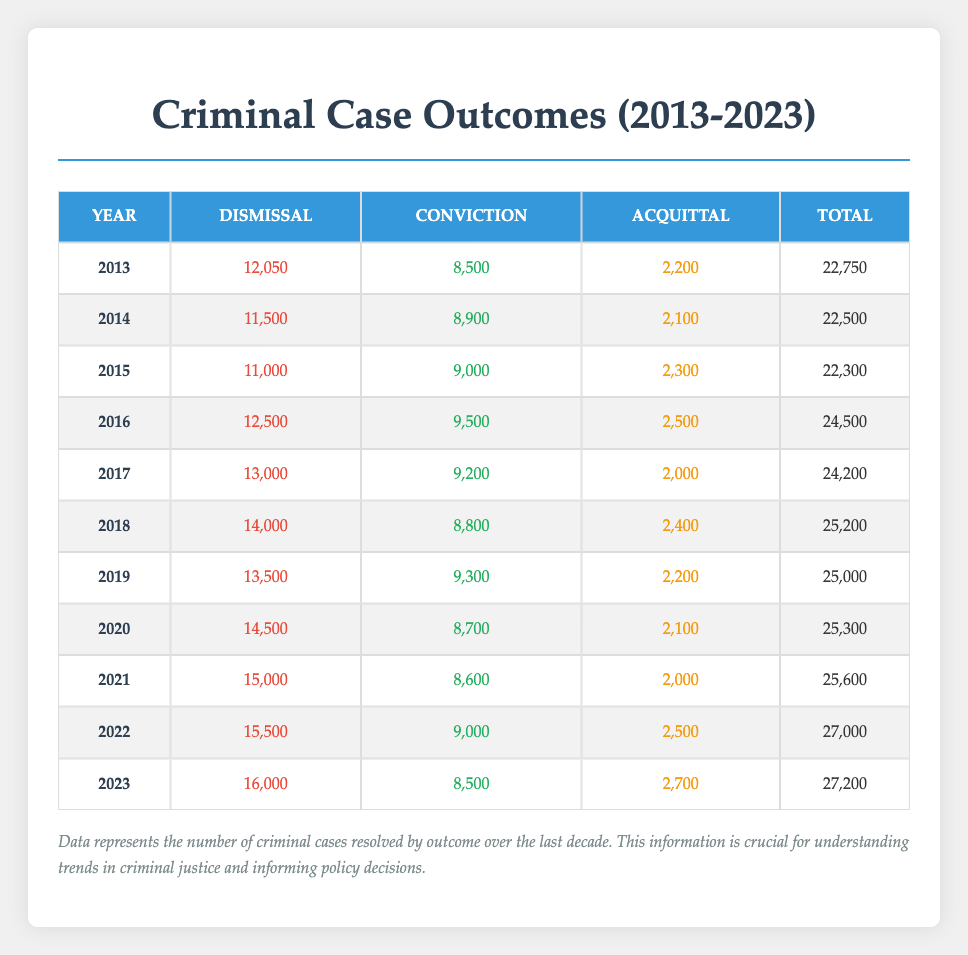What was the total number of criminal cases resolved in 2016? In 2016, the total number of criminal cases resolved is provided in the "Total" column, which shows 24,500 for that year.
Answer: 24,500 What year had the highest number of convictions? Looking at the "Conviction" column, the highest number of convictions is 9,500 in 2016.
Answer: 2016 What is the average number of dismissals over the last decade (2013-2023)? To find the average, sum the dismissals from each year (12050 + 11500 + 11000 + 12500 + 13000 + 14000 + 13500 + 14500 + 15000 + 15500 + 16000 = 144050) and divide by the number of years (11). Thus, the average is 144050/11 = 13004.55, rounded to 13005.
Answer: 13005 Did the number of acquittals increase every year from 2013 to 2023? By examining the "Acquittal" column, the numbers are 2200, 2100, 2300, 2500, 2000, 2400, 2200, 2100, 2000, 2500, 2700 respectively. The numbers do not consistently increase, specifically 2013 to 2014 and 2017 to 2018 show decreases.
Answer: No What was the total number of criminal cases resolved across all years in the decade? To find the total, sum each year's total (22,750 + 22,500 + 22,300 + 24,500 + 24,200 + 25,200 + 25,000 + 25,300 + 25,600 + 27,000 + 27,200 = 274,000).
Answer: 274,000 Which outcome category had consistently high numbers and what was the outcome in the last year (2023)? Reviewing the dismissals column, it shows an upward trend every year: from 12050 in 2013 to 16000 in 2023, showing it's consistently high. For 2023, the dismissal outcome was 16,000.
Answer: 16,000 In what year was the number of convictions the lowest, and how many were there? The lowest number of convictions can be found in the "Conviction" column, where the lowest value is 8,500 occurring in 2023.
Answer: 2023, 8,500 What is the difference in total outcomes (dismissal, conviction, and acquittal) between 2013 and 2023? To find the total outcomes for each year, add dismissals, convictions, and acquittals. For 2013: 12050 + 8500 + 2200 = 22,750, and for 2023: 16000 + 8500 + 2700 = 27,200. The difference is 27,200 - 22,750 = 4,450.
Answer: 4,450 